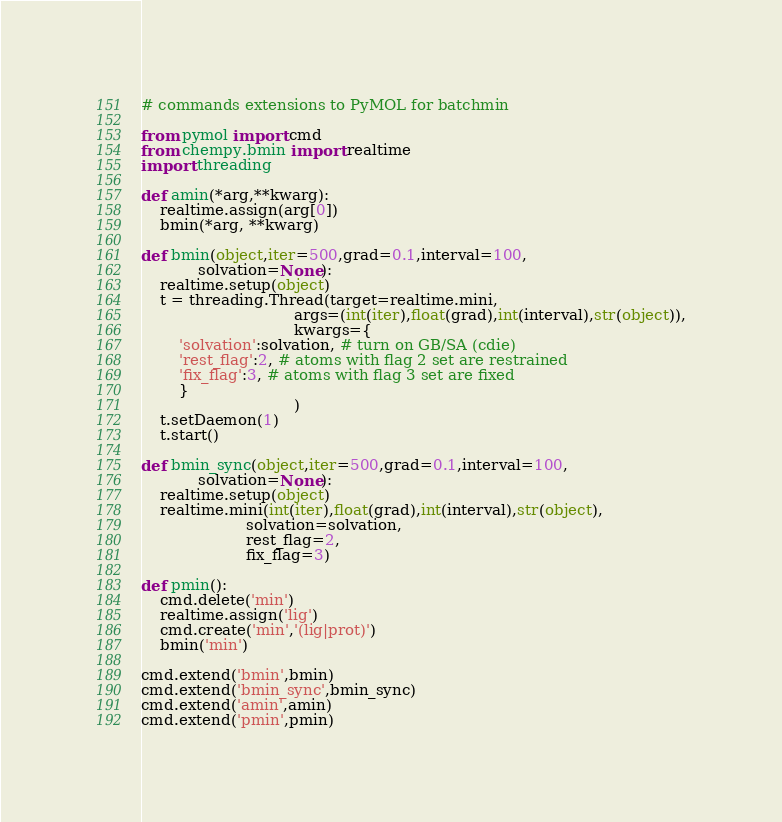Convert code to text. <code><loc_0><loc_0><loc_500><loc_500><_Python_># commands extensions to PyMOL for batchmin

from pymol import cmd
from chempy.bmin import realtime
import threading

def amin(*arg,**kwarg):
    realtime.assign(arg[0])
    bmin(*arg, **kwarg)

def bmin(object,iter=500,grad=0.1,interval=100,
            solvation=None):
    realtime.setup(object)
    t = threading.Thread(target=realtime.mini,
                                args=(int(iter),float(grad),int(interval),str(object)),
                                kwargs={
        'solvation':solvation, # turn on GB/SA (cdie)
        'rest_flag':2, # atoms with flag 2 set are restrained
        'fix_flag':3, # atoms with flag 3 set are fixed
        }
                                )
    t.setDaemon(1)
    t.start()

def bmin_sync(object,iter=500,grad=0.1,interval=100,
            solvation=None):
    realtime.setup(object)
    realtime.mini(int(iter),float(grad),int(interval),str(object),
                      solvation=solvation,
                      rest_flag=2,
                      fix_flag=3)

def pmin():
    cmd.delete('min')
    realtime.assign('lig')
    cmd.create('min','(lig|prot)')
    bmin('min')

cmd.extend('bmin',bmin)
cmd.extend('bmin_sync',bmin_sync)
cmd.extend('amin',amin)
cmd.extend('pmin',pmin)
</code> 